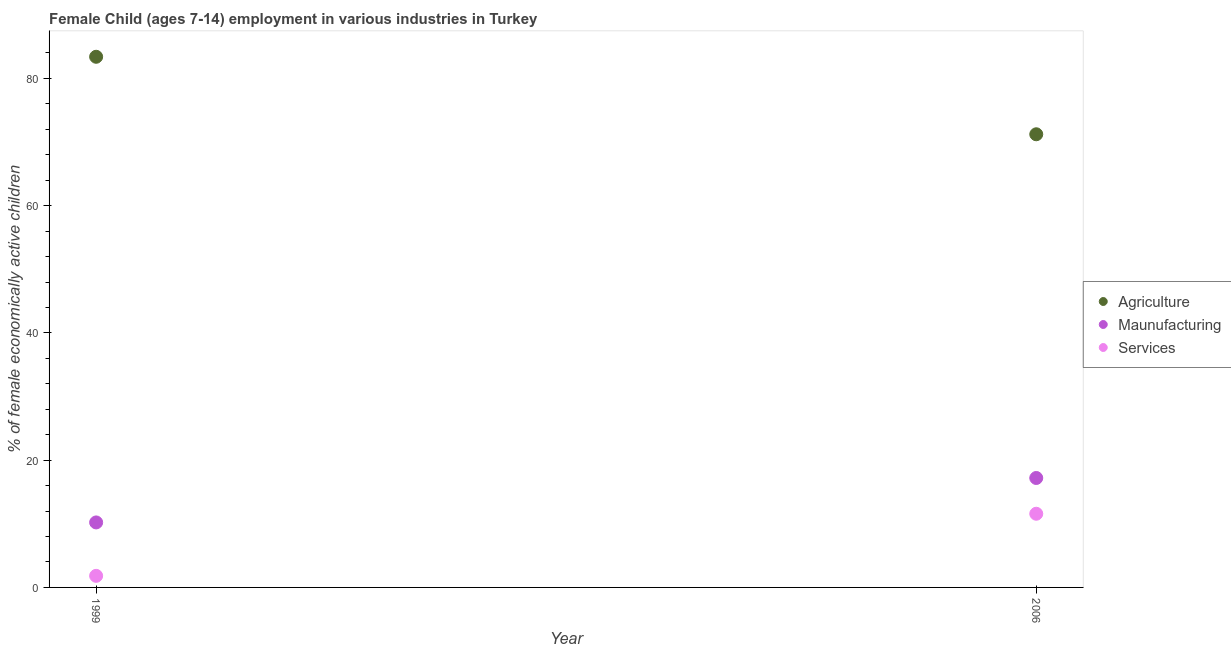Is the number of dotlines equal to the number of legend labels?
Make the answer very short. Yes. What is the percentage of economically active children in manufacturing in 1999?
Keep it short and to the point. 10.22. Across all years, what is the maximum percentage of economically active children in agriculture?
Your response must be concise. 83.4. Across all years, what is the minimum percentage of economically active children in services?
Offer a terse response. 1.82. In which year was the percentage of economically active children in services minimum?
Keep it short and to the point. 1999. What is the total percentage of economically active children in manufacturing in the graph?
Keep it short and to the point. 27.42. What is the difference between the percentage of economically active children in agriculture in 1999 and that in 2006?
Offer a very short reply. 12.18. What is the difference between the percentage of economically active children in manufacturing in 2006 and the percentage of economically active children in agriculture in 1999?
Keep it short and to the point. -66.2. What is the average percentage of economically active children in manufacturing per year?
Make the answer very short. 13.71. In the year 1999, what is the difference between the percentage of economically active children in agriculture and percentage of economically active children in services?
Offer a terse response. 81.58. In how many years, is the percentage of economically active children in agriculture greater than 16 %?
Make the answer very short. 2. What is the ratio of the percentage of economically active children in services in 1999 to that in 2006?
Provide a succinct answer. 0.16. Is the percentage of economically active children in manufacturing in 1999 less than that in 2006?
Keep it short and to the point. Yes. In how many years, is the percentage of economically active children in services greater than the average percentage of economically active children in services taken over all years?
Give a very brief answer. 1. Is the percentage of economically active children in agriculture strictly greater than the percentage of economically active children in services over the years?
Make the answer very short. Yes. Is the percentage of economically active children in manufacturing strictly less than the percentage of economically active children in agriculture over the years?
Your response must be concise. Yes. What is the difference between two consecutive major ticks on the Y-axis?
Provide a short and direct response. 20. Does the graph contain any zero values?
Your answer should be very brief. No. How are the legend labels stacked?
Provide a succinct answer. Vertical. What is the title of the graph?
Offer a terse response. Female Child (ages 7-14) employment in various industries in Turkey. What is the label or title of the Y-axis?
Offer a very short reply. % of female economically active children. What is the % of female economically active children of Agriculture in 1999?
Provide a succinct answer. 83.4. What is the % of female economically active children of Maunufacturing in 1999?
Your answer should be compact. 10.22. What is the % of female economically active children in Services in 1999?
Give a very brief answer. 1.82. What is the % of female economically active children in Agriculture in 2006?
Keep it short and to the point. 71.22. What is the % of female economically active children of Maunufacturing in 2006?
Your answer should be very brief. 17.2. What is the % of female economically active children of Services in 2006?
Offer a very short reply. 11.58. Across all years, what is the maximum % of female economically active children in Agriculture?
Your response must be concise. 83.4. Across all years, what is the maximum % of female economically active children in Maunufacturing?
Ensure brevity in your answer.  17.2. Across all years, what is the maximum % of female economically active children in Services?
Give a very brief answer. 11.58. Across all years, what is the minimum % of female economically active children of Agriculture?
Give a very brief answer. 71.22. Across all years, what is the minimum % of female economically active children of Maunufacturing?
Give a very brief answer. 10.22. Across all years, what is the minimum % of female economically active children of Services?
Your answer should be very brief. 1.82. What is the total % of female economically active children in Agriculture in the graph?
Make the answer very short. 154.62. What is the total % of female economically active children of Maunufacturing in the graph?
Ensure brevity in your answer.  27.42. What is the total % of female economically active children in Services in the graph?
Ensure brevity in your answer.  13.4. What is the difference between the % of female economically active children in Agriculture in 1999 and that in 2006?
Provide a succinct answer. 12.18. What is the difference between the % of female economically active children in Maunufacturing in 1999 and that in 2006?
Ensure brevity in your answer.  -6.98. What is the difference between the % of female economically active children in Services in 1999 and that in 2006?
Ensure brevity in your answer.  -9.76. What is the difference between the % of female economically active children in Agriculture in 1999 and the % of female economically active children in Maunufacturing in 2006?
Keep it short and to the point. 66.2. What is the difference between the % of female economically active children in Agriculture in 1999 and the % of female economically active children in Services in 2006?
Ensure brevity in your answer.  71.82. What is the difference between the % of female economically active children in Maunufacturing in 1999 and the % of female economically active children in Services in 2006?
Keep it short and to the point. -1.36. What is the average % of female economically active children of Agriculture per year?
Your answer should be compact. 77.31. What is the average % of female economically active children of Maunufacturing per year?
Ensure brevity in your answer.  13.71. What is the average % of female economically active children of Services per year?
Offer a terse response. 6.7. In the year 1999, what is the difference between the % of female economically active children in Agriculture and % of female economically active children in Maunufacturing?
Your response must be concise. 73.18. In the year 1999, what is the difference between the % of female economically active children of Agriculture and % of female economically active children of Services?
Your answer should be very brief. 81.58. In the year 1999, what is the difference between the % of female economically active children in Maunufacturing and % of female economically active children in Services?
Provide a succinct answer. 8.39. In the year 2006, what is the difference between the % of female economically active children in Agriculture and % of female economically active children in Maunufacturing?
Provide a short and direct response. 54.02. In the year 2006, what is the difference between the % of female economically active children in Agriculture and % of female economically active children in Services?
Your response must be concise. 59.64. In the year 2006, what is the difference between the % of female economically active children in Maunufacturing and % of female economically active children in Services?
Your answer should be compact. 5.62. What is the ratio of the % of female economically active children of Agriculture in 1999 to that in 2006?
Provide a short and direct response. 1.17. What is the ratio of the % of female economically active children in Maunufacturing in 1999 to that in 2006?
Make the answer very short. 0.59. What is the ratio of the % of female economically active children in Services in 1999 to that in 2006?
Give a very brief answer. 0.16. What is the difference between the highest and the second highest % of female economically active children in Agriculture?
Your answer should be very brief. 12.18. What is the difference between the highest and the second highest % of female economically active children of Maunufacturing?
Keep it short and to the point. 6.98. What is the difference between the highest and the second highest % of female economically active children in Services?
Your answer should be compact. 9.76. What is the difference between the highest and the lowest % of female economically active children of Agriculture?
Your answer should be compact. 12.18. What is the difference between the highest and the lowest % of female economically active children of Maunufacturing?
Provide a short and direct response. 6.98. What is the difference between the highest and the lowest % of female economically active children in Services?
Provide a short and direct response. 9.76. 